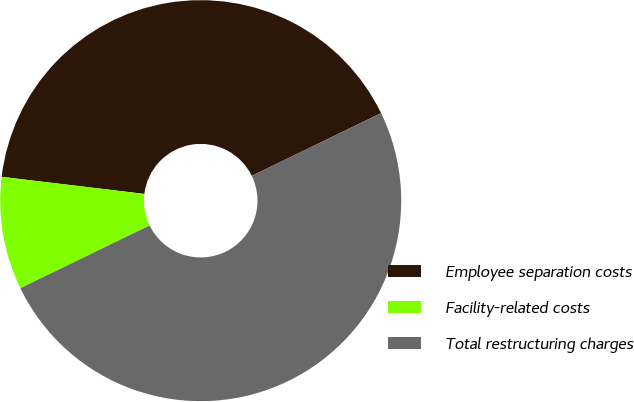Convert chart to OTSL. <chart><loc_0><loc_0><loc_500><loc_500><pie_chart><fcel>Employee separation costs<fcel>Facility-related costs<fcel>Total restructuring charges<nl><fcel>40.91%<fcel>9.09%<fcel>50.0%<nl></chart> 